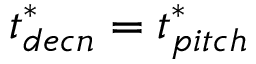Convert formula to latex. <formula><loc_0><loc_0><loc_500><loc_500>t _ { d e c n } ^ { * } = t _ { p i t c h } ^ { * }</formula> 